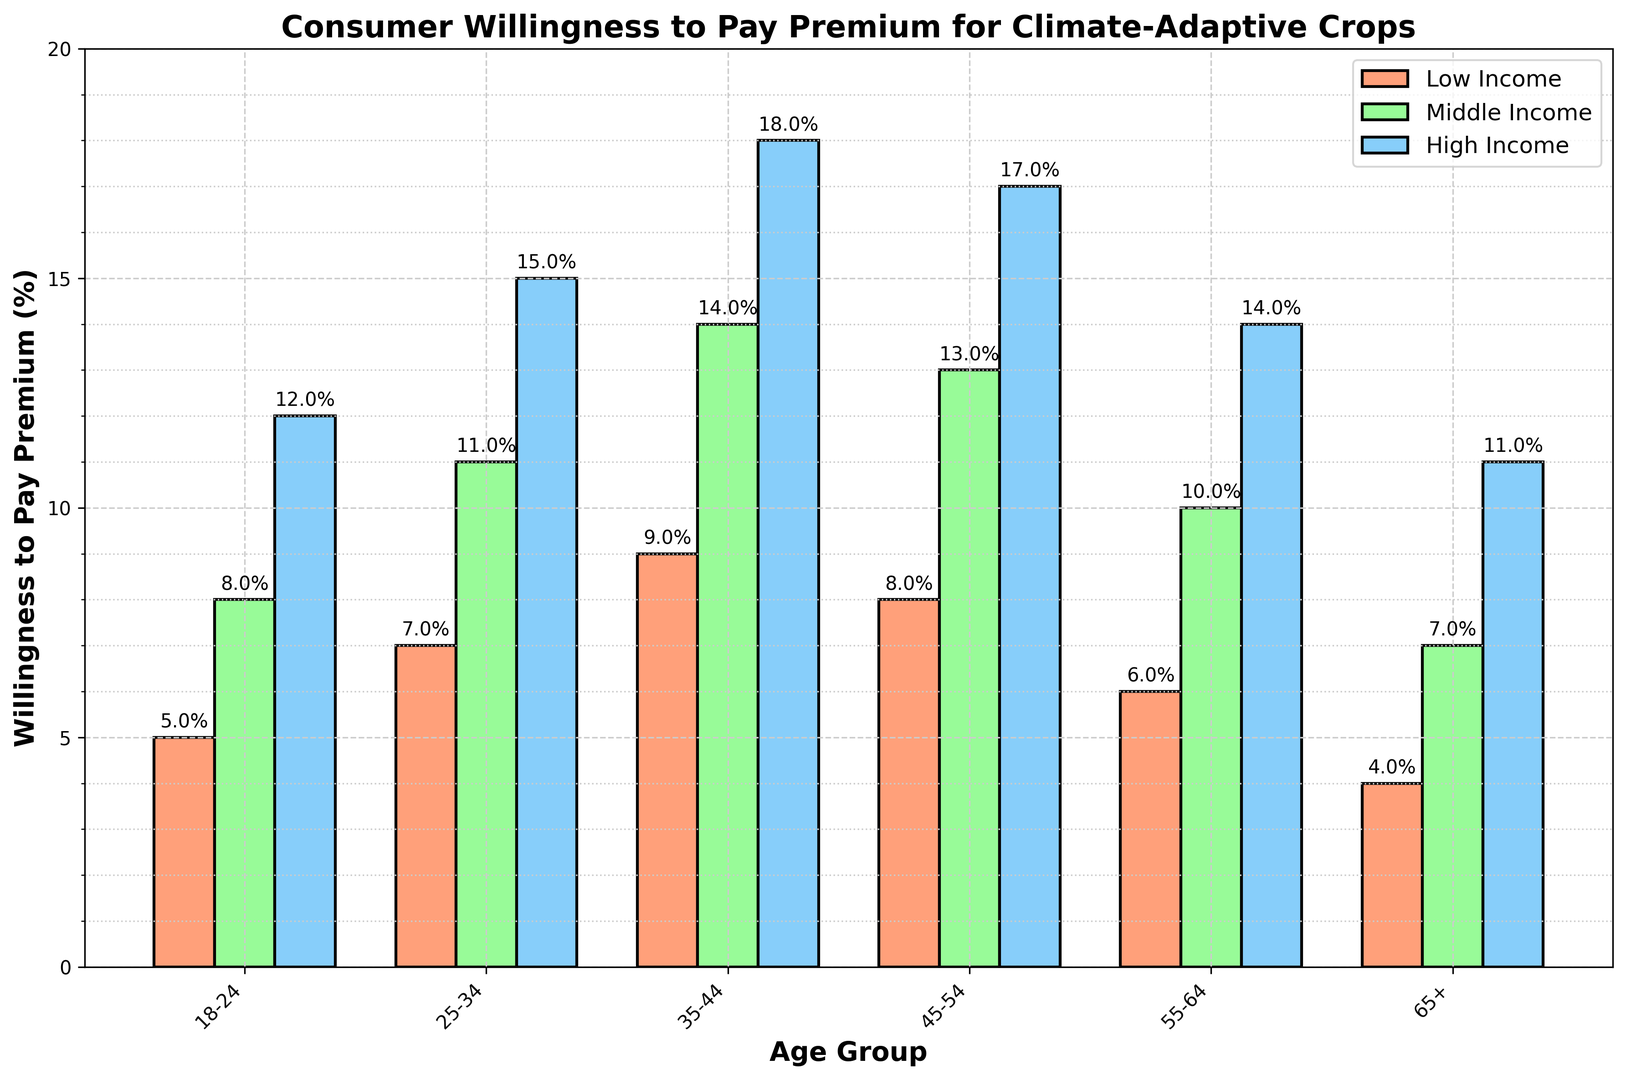What percentage of 35-44 year-olds in the middle-income bracket are willing to pay a premium? According to the chart, the bar for the 35-44 age group in the middle-income category indicates a willingness to pay of 14%.
Answer: 14% Which age group shows the highest willingness to pay among high-income consumers? The bar for the 35-44 age group in the high-income category is the tallest, indicating the highest willingness to pay at 18%.
Answer: 35-44 Which age group in the low-income bracket shows the lowest willingness to pay? The bar for the 65+ age group in the low-income category is the shortest, indicating the lowest willingness to pay at 4%.
Answer: 65+ What is the average willingness to pay premium for the 25-34 age group across all income levels? The percentages for the 25-34 age group are 7%, 11%, and 15% for low, middle, and high income respectively. The average is (7 + 11 + 15) / 3 = 11%.
Answer: 11% How much more willing are high-income consumers aged 45-54 to pay a premium compared to middle-income consumers aged 55-64? High-income consumers aged 45-54 are willing to pay 17%, and middle-income consumers aged 55-64 are willing to pay 10%. The difference is 17% - 10% = 7%.
Answer: 7% Which income group has the most variation in willingness to pay percentages across different age groups? The high-income bars range from 11% to 18%, a variation of 7%. The middle-income bars range from 7% to 14%, a variation of 7%. The low-income bars range from 4% to 9%, a variation of 5%. Middle and high-income groups both have the highest variation with 7%.
Answer: Middle and High Income What is the total willingness to pay percentage for all age groups combined within the high-income category? Summing the percentages for the high-income category: 12% (18-24) + 15% (25-34) + 18% (35-44) + 17% (45-54) + 14% (55-64) + 11% (65+) = 87%.
Answer: 87% Between which two consecutive age groups in the middle-income bracket is the increase in willingness to pay the greatest? The increases are: from 18-24 to 25-34 is 3% (11% - 8%), from 25-34 to 35-44 is 3% (14% - 11%), from 35-44 to 45-54 is -1% (13% - 14%), from 45-54 to 55-64 is -3% (10% - 13%), and from 55-64 to 65+ is -3% (7% - 10%). The greatest increase of 3% occurs from 18-24 to 25-34 and 25-34 to 35-44.
Answer: 18-24 to 25-34 and 25-34 to 35-44 